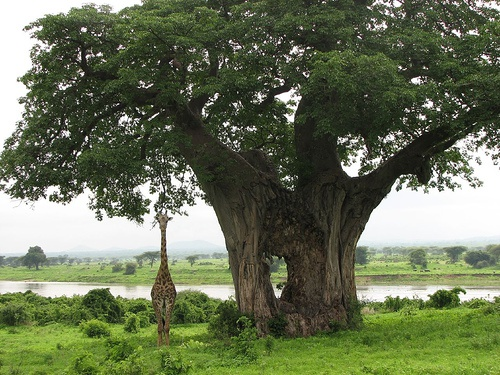Describe the objects in this image and their specific colors. I can see a giraffe in white, darkgreen, gray, and black tones in this image. 